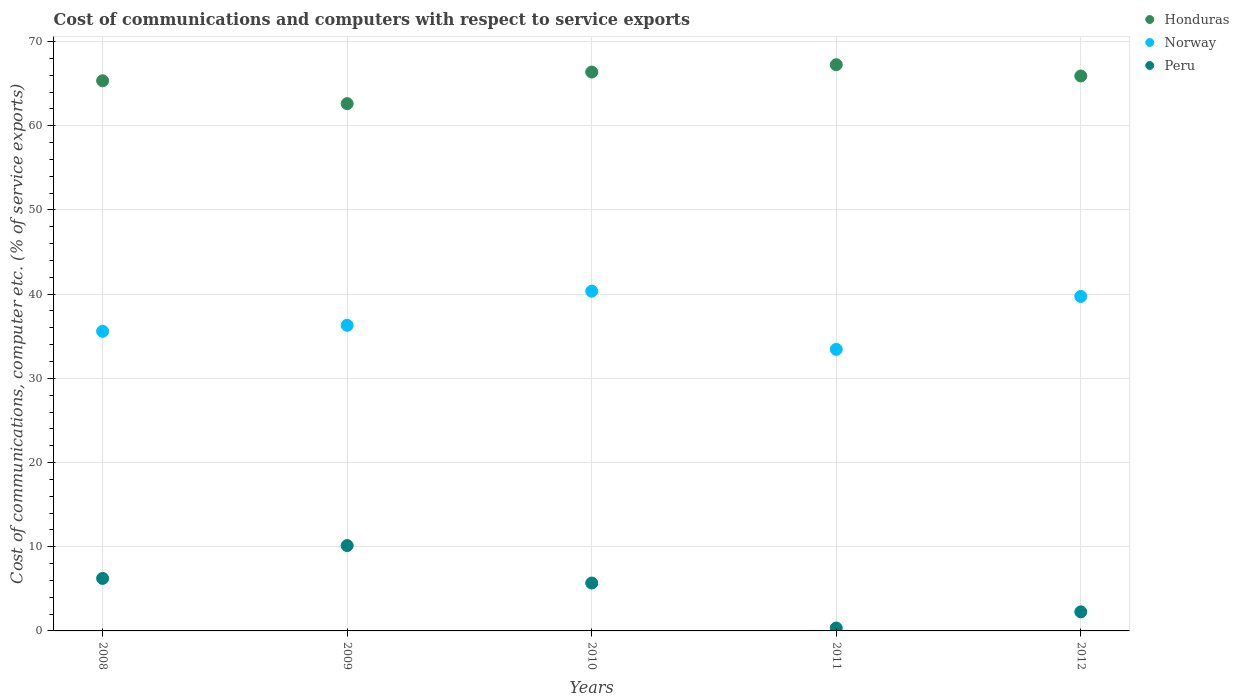What is the cost of communications and computers in Honduras in 2008?
Your answer should be compact. 65.34. Across all years, what is the maximum cost of communications and computers in Norway?
Your answer should be very brief. 40.35. Across all years, what is the minimum cost of communications and computers in Honduras?
Give a very brief answer. 62.63. In which year was the cost of communications and computers in Peru maximum?
Give a very brief answer. 2009. In which year was the cost of communications and computers in Peru minimum?
Your answer should be compact. 2011. What is the total cost of communications and computers in Honduras in the graph?
Offer a terse response. 327.5. What is the difference between the cost of communications and computers in Peru in 2009 and that in 2011?
Make the answer very short. 9.79. What is the difference between the cost of communications and computers in Norway in 2008 and the cost of communications and computers in Peru in 2009?
Your answer should be compact. 25.44. What is the average cost of communications and computers in Norway per year?
Your answer should be very brief. 37.08. In the year 2010, what is the difference between the cost of communications and computers in Honduras and cost of communications and computers in Peru?
Give a very brief answer. 60.69. In how many years, is the cost of communications and computers in Peru greater than 68 %?
Make the answer very short. 0. What is the ratio of the cost of communications and computers in Honduras in 2008 to that in 2012?
Give a very brief answer. 0.99. What is the difference between the highest and the second highest cost of communications and computers in Peru?
Offer a very short reply. 3.9. What is the difference between the highest and the lowest cost of communications and computers in Norway?
Keep it short and to the point. 6.91. Is it the case that in every year, the sum of the cost of communications and computers in Peru and cost of communications and computers in Norway  is greater than the cost of communications and computers in Honduras?
Your response must be concise. No. Does the cost of communications and computers in Peru monotonically increase over the years?
Provide a succinct answer. No. Is the cost of communications and computers in Norway strictly less than the cost of communications and computers in Honduras over the years?
Your response must be concise. Yes. How many dotlines are there?
Give a very brief answer. 3. Are the values on the major ticks of Y-axis written in scientific E-notation?
Offer a very short reply. No. Does the graph contain any zero values?
Your answer should be compact. No. Does the graph contain grids?
Your answer should be very brief. Yes. Where does the legend appear in the graph?
Offer a very short reply. Top right. How are the legend labels stacked?
Ensure brevity in your answer.  Vertical. What is the title of the graph?
Keep it short and to the point. Cost of communications and computers with respect to service exports. What is the label or title of the X-axis?
Provide a short and direct response. Years. What is the label or title of the Y-axis?
Provide a short and direct response. Cost of communications, computer etc. (% of service exports). What is the Cost of communications, computer etc. (% of service exports) of Honduras in 2008?
Your response must be concise. 65.34. What is the Cost of communications, computer etc. (% of service exports) in Norway in 2008?
Provide a succinct answer. 35.58. What is the Cost of communications, computer etc. (% of service exports) of Peru in 2008?
Offer a very short reply. 6.24. What is the Cost of communications, computer etc. (% of service exports) in Honduras in 2009?
Provide a short and direct response. 62.63. What is the Cost of communications, computer etc. (% of service exports) of Norway in 2009?
Offer a terse response. 36.3. What is the Cost of communications, computer etc. (% of service exports) in Peru in 2009?
Your response must be concise. 10.14. What is the Cost of communications, computer etc. (% of service exports) of Honduras in 2010?
Offer a terse response. 66.38. What is the Cost of communications, computer etc. (% of service exports) of Norway in 2010?
Your answer should be very brief. 40.35. What is the Cost of communications, computer etc. (% of service exports) of Peru in 2010?
Make the answer very short. 5.69. What is the Cost of communications, computer etc. (% of service exports) of Honduras in 2011?
Your response must be concise. 67.25. What is the Cost of communications, computer etc. (% of service exports) in Norway in 2011?
Offer a very short reply. 33.44. What is the Cost of communications, computer etc. (% of service exports) in Peru in 2011?
Your response must be concise. 0.35. What is the Cost of communications, computer etc. (% of service exports) of Honduras in 2012?
Give a very brief answer. 65.91. What is the Cost of communications, computer etc. (% of service exports) in Norway in 2012?
Offer a terse response. 39.72. What is the Cost of communications, computer etc. (% of service exports) of Peru in 2012?
Provide a short and direct response. 2.27. Across all years, what is the maximum Cost of communications, computer etc. (% of service exports) of Honduras?
Keep it short and to the point. 67.25. Across all years, what is the maximum Cost of communications, computer etc. (% of service exports) of Norway?
Provide a short and direct response. 40.35. Across all years, what is the maximum Cost of communications, computer etc. (% of service exports) of Peru?
Ensure brevity in your answer.  10.14. Across all years, what is the minimum Cost of communications, computer etc. (% of service exports) in Honduras?
Your answer should be compact. 62.63. Across all years, what is the minimum Cost of communications, computer etc. (% of service exports) of Norway?
Offer a terse response. 33.44. Across all years, what is the minimum Cost of communications, computer etc. (% of service exports) of Peru?
Offer a terse response. 0.35. What is the total Cost of communications, computer etc. (% of service exports) of Honduras in the graph?
Provide a succinct answer. 327.5. What is the total Cost of communications, computer etc. (% of service exports) of Norway in the graph?
Your answer should be compact. 185.39. What is the total Cost of communications, computer etc. (% of service exports) of Peru in the graph?
Make the answer very short. 24.67. What is the difference between the Cost of communications, computer etc. (% of service exports) in Honduras in 2008 and that in 2009?
Your response must be concise. 2.71. What is the difference between the Cost of communications, computer etc. (% of service exports) in Norway in 2008 and that in 2009?
Offer a very short reply. -0.71. What is the difference between the Cost of communications, computer etc. (% of service exports) in Peru in 2008 and that in 2009?
Make the answer very short. -3.9. What is the difference between the Cost of communications, computer etc. (% of service exports) of Honduras in 2008 and that in 2010?
Your answer should be very brief. -1.04. What is the difference between the Cost of communications, computer etc. (% of service exports) in Norway in 2008 and that in 2010?
Keep it short and to the point. -4.77. What is the difference between the Cost of communications, computer etc. (% of service exports) of Peru in 2008 and that in 2010?
Offer a terse response. 0.55. What is the difference between the Cost of communications, computer etc. (% of service exports) of Honduras in 2008 and that in 2011?
Give a very brief answer. -1.91. What is the difference between the Cost of communications, computer etc. (% of service exports) of Norway in 2008 and that in 2011?
Offer a very short reply. 2.14. What is the difference between the Cost of communications, computer etc. (% of service exports) in Peru in 2008 and that in 2011?
Your response must be concise. 5.89. What is the difference between the Cost of communications, computer etc. (% of service exports) in Honduras in 2008 and that in 2012?
Offer a very short reply. -0.57. What is the difference between the Cost of communications, computer etc. (% of service exports) of Norway in 2008 and that in 2012?
Ensure brevity in your answer.  -4.14. What is the difference between the Cost of communications, computer etc. (% of service exports) of Peru in 2008 and that in 2012?
Provide a short and direct response. 3.97. What is the difference between the Cost of communications, computer etc. (% of service exports) in Honduras in 2009 and that in 2010?
Make the answer very short. -3.75. What is the difference between the Cost of communications, computer etc. (% of service exports) of Norway in 2009 and that in 2010?
Provide a succinct answer. -4.05. What is the difference between the Cost of communications, computer etc. (% of service exports) of Peru in 2009 and that in 2010?
Offer a terse response. 4.45. What is the difference between the Cost of communications, computer etc. (% of service exports) of Honduras in 2009 and that in 2011?
Keep it short and to the point. -4.62. What is the difference between the Cost of communications, computer etc. (% of service exports) in Norway in 2009 and that in 2011?
Give a very brief answer. 2.86. What is the difference between the Cost of communications, computer etc. (% of service exports) of Peru in 2009 and that in 2011?
Keep it short and to the point. 9.79. What is the difference between the Cost of communications, computer etc. (% of service exports) in Honduras in 2009 and that in 2012?
Offer a very short reply. -3.28. What is the difference between the Cost of communications, computer etc. (% of service exports) of Norway in 2009 and that in 2012?
Make the answer very short. -3.43. What is the difference between the Cost of communications, computer etc. (% of service exports) in Peru in 2009 and that in 2012?
Make the answer very short. 7.87. What is the difference between the Cost of communications, computer etc. (% of service exports) in Honduras in 2010 and that in 2011?
Provide a succinct answer. -0.87. What is the difference between the Cost of communications, computer etc. (% of service exports) in Norway in 2010 and that in 2011?
Your answer should be very brief. 6.91. What is the difference between the Cost of communications, computer etc. (% of service exports) in Peru in 2010 and that in 2011?
Your response must be concise. 5.34. What is the difference between the Cost of communications, computer etc. (% of service exports) of Honduras in 2010 and that in 2012?
Your response must be concise. 0.47. What is the difference between the Cost of communications, computer etc. (% of service exports) in Norway in 2010 and that in 2012?
Your answer should be very brief. 0.63. What is the difference between the Cost of communications, computer etc. (% of service exports) in Peru in 2010 and that in 2012?
Your answer should be very brief. 3.42. What is the difference between the Cost of communications, computer etc. (% of service exports) of Honduras in 2011 and that in 2012?
Your answer should be very brief. 1.34. What is the difference between the Cost of communications, computer etc. (% of service exports) of Norway in 2011 and that in 2012?
Make the answer very short. -6.29. What is the difference between the Cost of communications, computer etc. (% of service exports) of Peru in 2011 and that in 2012?
Make the answer very short. -1.92. What is the difference between the Cost of communications, computer etc. (% of service exports) in Honduras in 2008 and the Cost of communications, computer etc. (% of service exports) in Norway in 2009?
Provide a short and direct response. 29.04. What is the difference between the Cost of communications, computer etc. (% of service exports) of Honduras in 2008 and the Cost of communications, computer etc. (% of service exports) of Peru in 2009?
Offer a terse response. 55.2. What is the difference between the Cost of communications, computer etc. (% of service exports) of Norway in 2008 and the Cost of communications, computer etc. (% of service exports) of Peru in 2009?
Keep it short and to the point. 25.44. What is the difference between the Cost of communications, computer etc. (% of service exports) in Honduras in 2008 and the Cost of communications, computer etc. (% of service exports) in Norway in 2010?
Give a very brief answer. 24.99. What is the difference between the Cost of communications, computer etc. (% of service exports) in Honduras in 2008 and the Cost of communications, computer etc. (% of service exports) in Peru in 2010?
Provide a short and direct response. 59.65. What is the difference between the Cost of communications, computer etc. (% of service exports) of Norway in 2008 and the Cost of communications, computer etc. (% of service exports) of Peru in 2010?
Make the answer very short. 29.9. What is the difference between the Cost of communications, computer etc. (% of service exports) in Honduras in 2008 and the Cost of communications, computer etc. (% of service exports) in Norway in 2011?
Provide a short and direct response. 31.9. What is the difference between the Cost of communications, computer etc. (% of service exports) in Honduras in 2008 and the Cost of communications, computer etc. (% of service exports) in Peru in 2011?
Keep it short and to the point. 64.99. What is the difference between the Cost of communications, computer etc. (% of service exports) of Norway in 2008 and the Cost of communications, computer etc. (% of service exports) of Peru in 2011?
Offer a terse response. 35.23. What is the difference between the Cost of communications, computer etc. (% of service exports) of Honduras in 2008 and the Cost of communications, computer etc. (% of service exports) of Norway in 2012?
Your answer should be very brief. 25.61. What is the difference between the Cost of communications, computer etc. (% of service exports) of Honduras in 2008 and the Cost of communications, computer etc. (% of service exports) of Peru in 2012?
Keep it short and to the point. 63.07. What is the difference between the Cost of communications, computer etc. (% of service exports) in Norway in 2008 and the Cost of communications, computer etc. (% of service exports) in Peru in 2012?
Ensure brevity in your answer.  33.32. What is the difference between the Cost of communications, computer etc. (% of service exports) in Honduras in 2009 and the Cost of communications, computer etc. (% of service exports) in Norway in 2010?
Ensure brevity in your answer.  22.27. What is the difference between the Cost of communications, computer etc. (% of service exports) of Honduras in 2009 and the Cost of communications, computer etc. (% of service exports) of Peru in 2010?
Ensure brevity in your answer.  56.94. What is the difference between the Cost of communications, computer etc. (% of service exports) in Norway in 2009 and the Cost of communications, computer etc. (% of service exports) in Peru in 2010?
Offer a terse response. 30.61. What is the difference between the Cost of communications, computer etc. (% of service exports) in Honduras in 2009 and the Cost of communications, computer etc. (% of service exports) in Norway in 2011?
Make the answer very short. 29.19. What is the difference between the Cost of communications, computer etc. (% of service exports) of Honduras in 2009 and the Cost of communications, computer etc. (% of service exports) of Peru in 2011?
Your response must be concise. 62.28. What is the difference between the Cost of communications, computer etc. (% of service exports) in Norway in 2009 and the Cost of communications, computer etc. (% of service exports) in Peru in 2011?
Ensure brevity in your answer.  35.95. What is the difference between the Cost of communications, computer etc. (% of service exports) in Honduras in 2009 and the Cost of communications, computer etc. (% of service exports) in Norway in 2012?
Offer a terse response. 22.9. What is the difference between the Cost of communications, computer etc. (% of service exports) in Honduras in 2009 and the Cost of communications, computer etc. (% of service exports) in Peru in 2012?
Provide a short and direct response. 60.36. What is the difference between the Cost of communications, computer etc. (% of service exports) of Norway in 2009 and the Cost of communications, computer etc. (% of service exports) of Peru in 2012?
Your answer should be compact. 34.03. What is the difference between the Cost of communications, computer etc. (% of service exports) in Honduras in 2010 and the Cost of communications, computer etc. (% of service exports) in Norway in 2011?
Your answer should be compact. 32.94. What is the difference between the Cost of communications, computer etc. (% of service exports) of Honduras in 2010 and the Cost of communications, computer etc. (% of service exports) of Peru in 2011?
Provide a short and direct response. 66.03. What is the difference between the Cost of communications, computer etc. (% of service exports) in Norway in 2010 and the Cost of communications, computer etc. (% of service exports) in Peru in 2011?
Your answer should be compact. 40. What is the difference between the Cost of communications, computer etc. (% of service exports) of Honduras in 2010 and the Cost of communications, computer etc. (% of service exports) of Norway in 2012?
Offer a terse response. 26.65. What is the difference between the Cost of communications, computer etc. (% of service exports) of Honduras in 2010 and the Cost of communications, computer etc. (% of service exports) of Peru in 2012?
Make the answer very short. 64.11. What is the difference between the Cost of communications, computer etc. (% of service exports) in Norway in 2010 and the Cost of communications, computer etc. (% of service exports) in Peru in 2012?
Provide a succinct answer. 38.08. What is the difference between the Cost of communications, computer etc. (% of service exports) of Honduras in 2011 and the Cost of communications, computer etc. (% of service exports) of Norway in 2012?
Make the answer very short. 27.52. What is the difference between the Cost of communications, computer etc. (% of service exports) of Honduras in 2011 and the Cost of communications, computer etc. (% of service exports) of Peru in 2012?
Ensure brevity in your answer.  64.98. What is the difference between the Cost of communications, computer etc. (% of service exports) of Norway in 2011 and the Cost of communications, computer etc. (% of service exports) of Peru in 2012?
Make the answer very short. 31.17. What is the average Cost of communications, computer etc. (% of service exports) of Honduras per year?
Ensure brevity in your answer.  65.5. What is the average Cost of communications, computer etc. (% of service exports) of Norway per year?
Ensure brevity in your answer.  37.08. What is the average Cost of communications, computer etc. (% of service exports) of Peru per year?
Your response must be concise. 4.93. In the year 2008, what is the difference between the Cost of communications, computer etc. (% of service exports) in Honduras and Cost of communications, computer etc. (% of service exports) in Norway?
Make the answer very short. 29.76. In the year 2008, what is the difference between the Cost of communications, computer etc. (% of service exports) in Honduras and Cost of communications, computer etc. (% of service exports) in Peru?
Offer a terse response. 59.1. In the year 2008, what is the difference between the Cost of communications, computer etc. (% of service exports) of Norway and Cost of communications, computer etc. (% of service exports) of Peru?
Give a very brief answer. 29.35. In the year 2009, what is the difference between the Cost of communications, computer etc. (% of service exports) of Honduras and Cost of communications, computer etc. (% of service exports) of Norway?
Offer a very short reply. 26.33. In the year 2009, what is the difference between the Cost of communications, computer etc. (% of service exports) in Honduras and Cost of communications, computer etc. (% of service exports) in Peru?
Make the answer very short. 52.49. In the year 2009, what is the difference between the Cost of communications, computer etc. (% of service exports) of Norway and Cost of communications, computer etc. (% of service exports) of Peru?
Make the answer very short. 26.16. In the year 2010, what is the difference between the Cost of communications, computer etc. (% of service exports) in Honduras and Cost of communications, computer etc. (% of service exports) in Norway?
Make the answer very short. 26.03. In the year 2010, what is the difference between the Cost of communications, computer etc. (% of service exports) of Honduras and Cost of communications, computer etc. (% of service exports) of Peru?
Your response must be concise. 60.69. In the year 2010, what is the difference between the Cost of communications, computer etc. (% of service exports) of Norway and Cost of communications, computer etc. (% of service exports) of Peru?
Ensure brevity in your answer.  34.67. In the year 2011, what is the difference between the Cost of communications, computer etc. (% of service exports) in Honduras and Cost of communications, computer etc. (% of service exports) in Norway?
Make the answer very short. 33.81. In the year 2011, what is the difference between the Cost of communications, computer etc. (% of service exports) of Honduras and Cost of communications, computer etc. (% of service exports) of Peru?
Your answer should be compact. 66.9. In the year 2011, what is the difference between the Cost of communications, computer etc. (% of service exports) of Norway and Cost of communications, computer etc. (% of service exports) of Peru?
Your answer should be very brief. 33.09. In the year 2012, what is the difference between the Cost of communications, computer etc. (% of service exports) of Honduras and Cost of communications, computer etc. (% of service exports) of Norway?
Provide a succinct answer. 26.19. In the year 2012, what is the difference between the Cost of communications, computer etc. (% of service exports) in Honduras and Cost of communications, computer etc. (% of service exports) in Peru?
Your answer should be compact. 63.64. In the year 2012, what is the difference between the Cost of communications, computer etc. (% of service exports) of Norway and Cost of communications, computer etc. (% of service exports) of Peru?
Your answer should be very brief. 37.46. What is the ratio of the Cost of communications, computer etc. (% of service exports) in Honduras in 2008 to that in 2009?
Give a very brief answer. 1.04. What is the ratio of the Cost of communications, computer etc. (% of service exports) of Norway in 2008 to that in 2009?
Provide a succinct answer. 0.98. What is the ratio of the Cost of communications, computer etc. (% of service exports) of Peru in 2008 to that in 2009?
Provide a short and direct response. 0.62. What is the ratio of the Cost of communications, computer etc. (% of service exports) of Honduras in 2008 to that in 2010?
Offer a terse response. 0.98. What is the ratio of the Cost of communications, computer etc. (% of service exports) of Norway in 2008 to that in 2010?
Keep it short and to the point. 0.88. What is the ratio of the Cost of communications, computer etc. (% of service exports) of Peru in 2008 to that in 2010?
Offer a very short reply. 1.1. What is the ratio of the Cost of communications, computer etc. (% of service exports) of Honduras in 2008 to that in 2011?
Make the answer very short. 0.97. What is the ratio of the Cost of communications, computer etc. (% of service exports) of Norway in 2008 to that in 2011?
Give a very brief answer. 1.06. What is the ratio of the Cost of communications, computer etc. (% of service exports) of Peru in 2008 to that in 2011?
Give a very brief answer. 17.96. What is the ratio of the Cost of communications, computer etc. (% of service exports) of Norway in 2008 to that in 2012?
Provide a succinct answer. 0.9. What is the ratio of the Cost of communications, computer etc. (% of service exports) in Peru in 2008 to that in 2012?
Give a very brief answer. 2.75. What is the ratio of the Cost of communications, computer etc. (% of service exports) of Honduras in 2009 to that in 2010?
Offer a terse response. 0.94. What is the ratio of the Cost of communications, computer etc. (% of service exports) of Norway in 2009 to that in 2010?
Offer a very short reply. 0.9. What is the ratio of the Cost of communications, computer etc. (% of service exports) of Peru in 2009 to that in 2010?
Ensure brevity in your answer.  1.78. What is the ratio of the Cost of communications, computer etc. (% of service exports) in Honduras in 2009 to that in 2011?
Offer a terse response. 0.93. What is the ratio of the Cost of communications, computer etc. (% of service exports) of Norway in 2009 to that in 2011?
Provide a succinct answer. 1.09. What is the ratio of the Cost of communications, computer etc. (% of service exports) in Peru in 2009 to that in 2011?
Provide a succinct answer. 29.19. What is the ratio of the Cost of communications, computer etc. (% of service exports) in Honduras in 2009 to that in 2012?
Offer a very short reply. 0.95. What is the ratio of the Cost of communications, computer etc. (% of service exports) of Norway in 2009 to that in 2012?
Ensure brevity in your answer.  0.91. What is the ratio of the Cost of communications, computer etc. (% of service exports) of Peru in 2009 to that in 2012?
Your response must be concise. 4.47. What is the ratio of the Cost of communications, computer etc. (% of service exports) in Honduras in 2010 to that in 2011?
Provide a short and direct response. 0.99. What is the ratio of the Cost of communications, computer etc. (% of service exports) in Norway in 2010 to that in 2011?
Your answer should be compact. 1.21. What is the ratio of the Cost of communications, computer etc. (% of service exports) of Peru in 2010 to that in 2011?
Your response must be concise. 16.37. What is the ratio of the Cost of communications, computer etc. (% of service exports) in Honduras in 2010 to that in 2012?
Make the answer very short. 1.01. What is the ratio of the Cost of communications, computer etc. (% of service exports) in Norway in 2010 to that in 2012?
Ensure brevity in your answer.  1.02. What is the ratio of the Cost of communications, computer etc. (% of service exports) in Peru in 2010 to that in 2012?
Ensure brevity in your answer.  2.51. What is the ratio of the Cost of communications, computer etc. (% of service exports) of Honduras in 2011 to that in 2012?
Give a very brief answer. 1.02. What is the ratio of the Cost of communications, computer etc. (% of service exports) in Norway in 2011 to that in 2012?
Make the answer very short. 0.84. What is the ratio of the Cost of communications, computer etc. (% of service exports) in Peru in 2011 to that in 2012?
Your answer should be compact. 0.15. What is the difference between the highest and the second highest Cost of communications, computer etc. (% of service exports) in Honduras?
Keep it short and to the point. 0.87. What is the difference between the highest and the second highest Cost of communications, computer etc. (% of service exports) in Norway?
Make the answer very short. 0.63. What is the difference between the highest and the second highest Cost of communications, computer etc. (% of service exports) in Peru?
Make the answer very short. 3.9. What is the difference between the highest and the lowest Cost of communications, computer etc. (% of service exports) in Honduras?
Provide a short and direct response. 4.62. What is the difference between the highest and the lowest Cost of communications, computer etc. (% of service exports) of Norway?
Offer a very short reply. 6.91. What is the difference between the highest and the lowest Cost of communications, computer etc. (% of service exports) of Peru?
Keep it short and to the point. 9.79. 